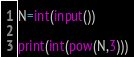<code> <loc_0><loc_0><loc_500><loc_500><_Python_>
N=int(input())

print(int(pow(N,3)))</code> 